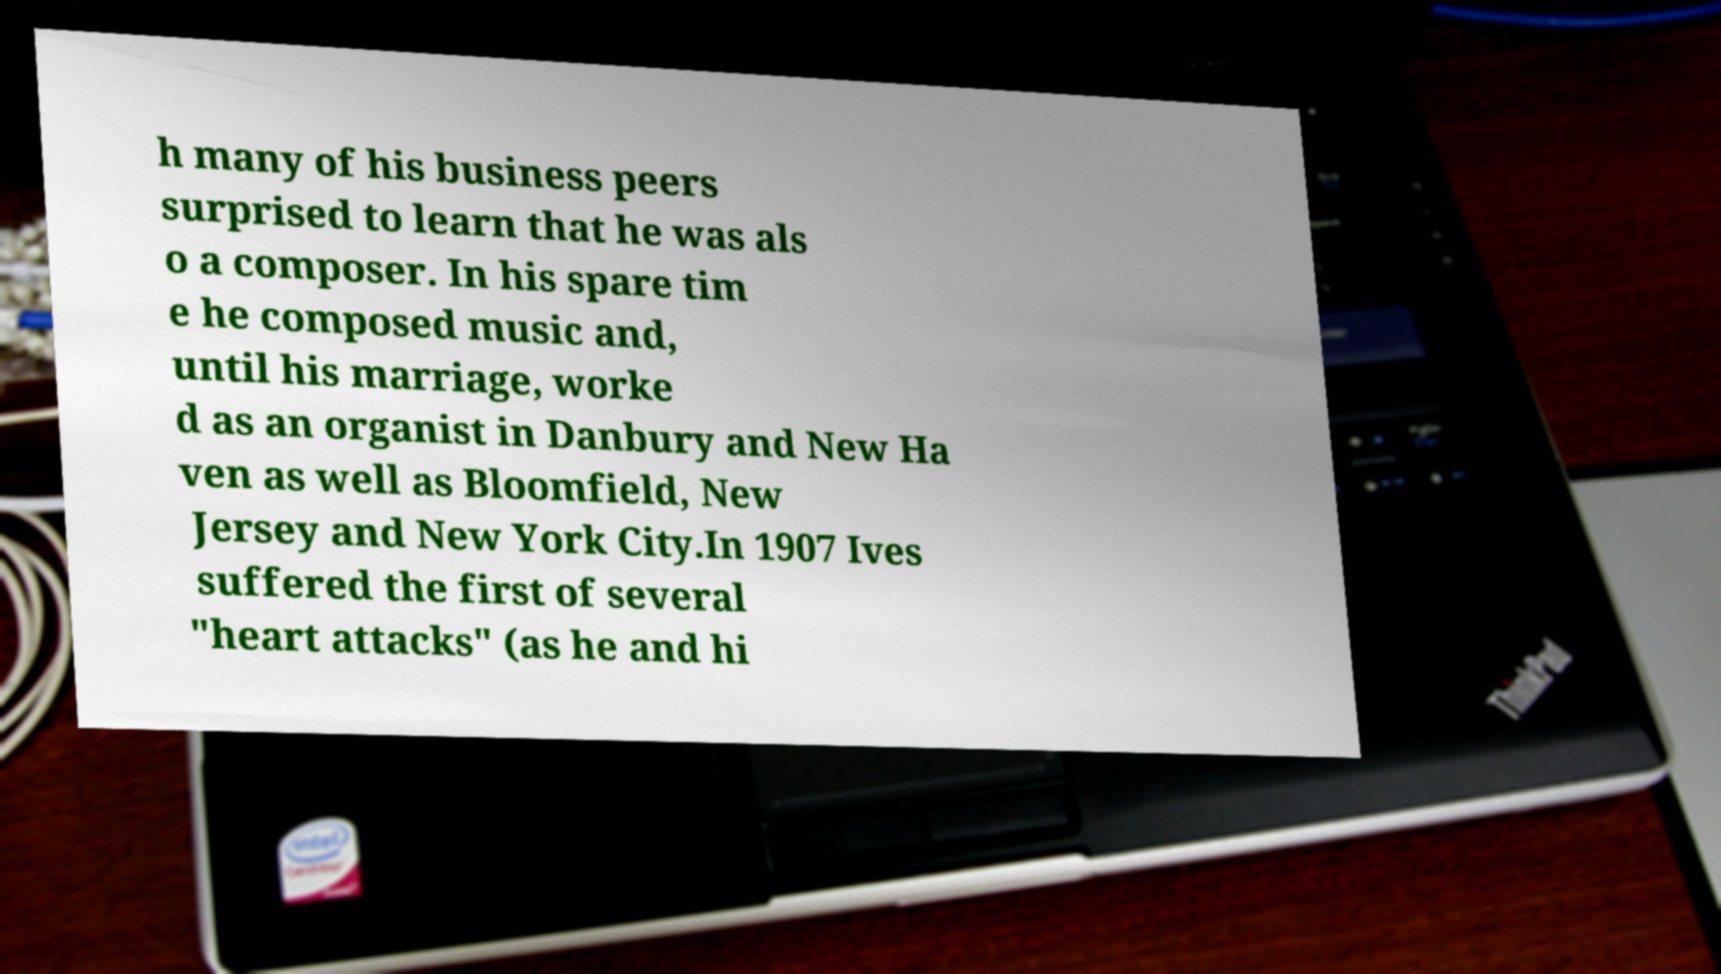Could you extract and type out the text from this image? h many of his business peers surprised to learn that he was als o a composer. In his spare tim e he composed music and, until his marriage, worke d as an organist in Danbury and New Ha ven as well as Bloomfield, New Jersey and New York City.In 1907 Ives suffered the first of several "heart attacks" (as he and hi 